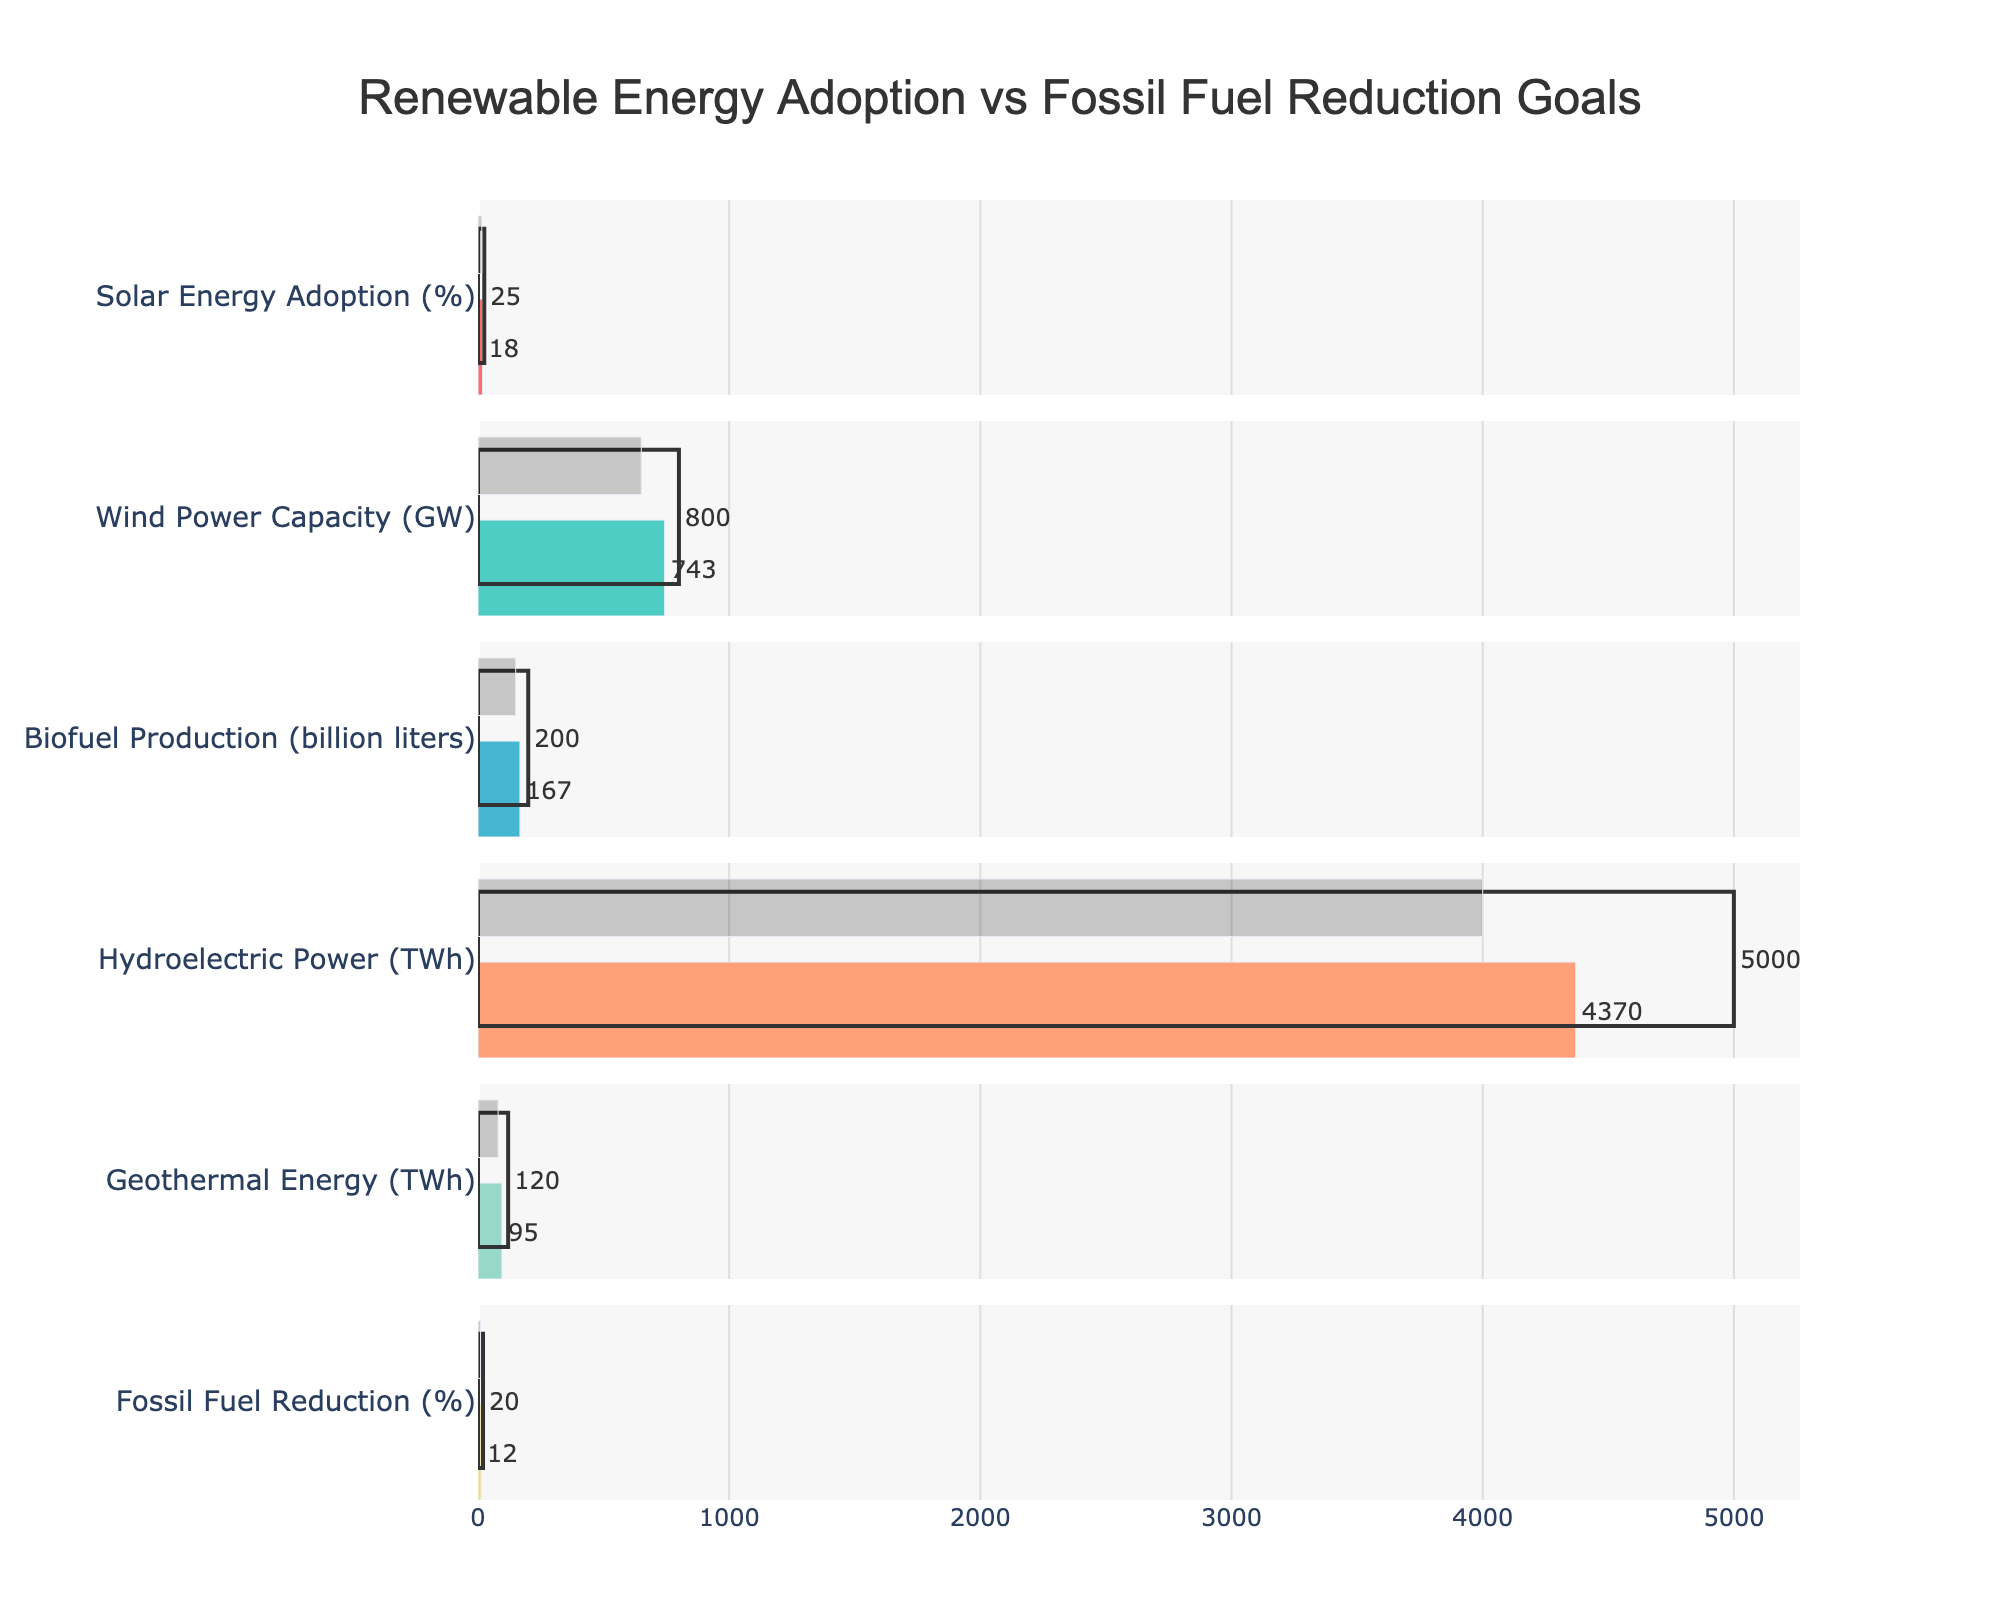What's the title of the figure? The title is usually prominently displayed at the top of the figure, making it easy to identify. Look for large, bold text.
Answer: Renewable Energy Adoption vs Fossil Fuel Reduction Goals What are the categories represented in the bullet chart? Categories are typically listed on the y-axis. By reading them, we can identify all the categories that are part of the chart.
Answer: Solar Energy Adoption (%), Wind Power Capacity (GW), Biofuel Production (billion liters), Hydroelectric Power (TWh), Geothermal Energy (TWh), Fossil Fuel Reduction (%) How does the actual Solar Energy Adoption percentage compare to the target? Identify the bars relating to Solar Energy Adoption, then compare the length of the "Actual" bar to the "Target" bar.
Answer: The actual Solar Energy Adoption is 7% less than the target (18% actual vs. 25% target) What is the difference between the target and comparative values for Wind Power Capacity? Find the target and comparative bars for Wind Power Capacity and subtract the comparative value from the target value.
Answer: The difference between target and comparative values is 150 GW (800 GW target - 650 GW comparative) Which category has the highest actual value among renewable energy sources? Examine the lengths of the "Actual" bars for each renewable energy source and identify the longest one.
Answer: Hydroelectric Power (4370 TWh) How much more biofuel production is needed to reach the target compared to the actual production? Find the actual and target bars for Biofuel Production and subtract the actual value from the target value.
Answer: 33 billion liters (200 billion liters target - 167 billion liters actual) Is the comparative value for Geothermal Energy higher or lower than the actual value? Locate the "Actual" and "Comparative" bars for Geothermal Energy and compare their lengths.
Answer: Lower (80 TWh comparative vs. 95 TWh actual) What is the sum of the actual values for all energy categories? Add up all the actual values listed for each category.
Answer: 5465 (18% + 743 GW + 167 billion liters + 4370 TWh + 95 TWh + 12%) By how much does the actual Fossil Fuel Reduction fall short of the target? Subtract the actual value from the target value for the Fossil Fuel Reduction category.
Answer: 8% (20% target - 12% actual) Which renewable energy category has the smallest difference between the actual and the target values? Calculate the difference between the actual and target values for each renewable energy category and find the smallest one.
Answer: Solar Energy Adoption (%): 7% (25% target - 18% actual) 